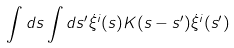Convert formula to latex. <formula><loc_0><loc_0><loc_500><loc_500>\int d s \int d s ^ { \prime } \dot { \xi } ^ { i } ( s ) K ( s - s ^ { \prime } ) \dot { \xi } ^ { i } ( s ^ { \prime } )</formula> 